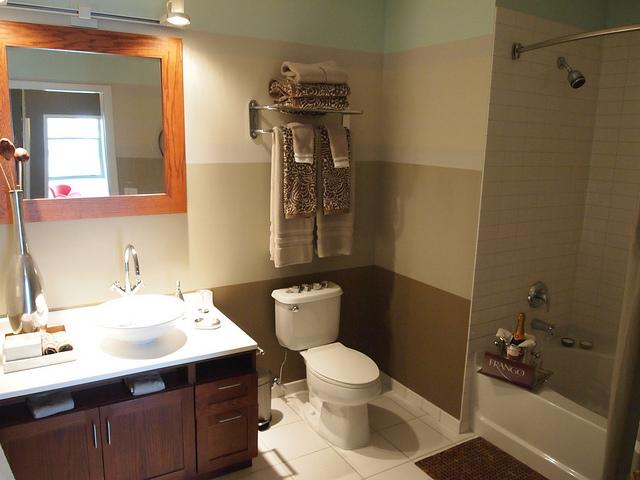Which color is dominant?
Concise answer only. Brown. What color are the towels?
Answer briefly. Brown. How many toilets are in this room?
Concise answer only. 1. What is in the mirror's reflection?
Keep it brief. Window. What color is the walls?
Be succinct. Brown. How many mirrors are in this scene?
Short answer required. 1. How are the walls painted?
Write a very short answer. Multicolored. What type of flooring is in this room?
Answer briefly. Tile. 